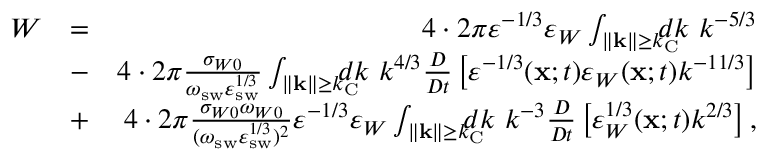<formula> <loc_0><loc_0><loc_500><loc_500>\begin{array} { r l r } { W } & { = } & { 4 \cdot 2 \pi \varepsilon ^ { - 1 / 3 } \varepsilon _ { W } \int _ { \| { k } \| \geq k _ { C } } \, d k \ k ^ { - 5 / 3 } } \\ & { - } & { 4 \cdot 2 \pi \frac { \sigma _ { W 0 } } { \omega _ { s w } \varepsilon _ { s w } ^ { 1 / 3 } } \int _ { \| { k } \| \geq k _ { C } } \, d k \ k ^ { 4 / 3 } \frac { D } { D t } \left [ { \varepsilon ^ { - 1 / 3 } ( { x } ; t ) \varepsilon _ { W } ( { x } ; t ) k ^ { - 1 1 / 3 } } \right ] } \\ & { + } & { 4 \cdot 2 \pi \frac { \sigma _ { W 0 } \omega _ { W 0 } } { ( \omega _ { s w } \varepsilon _ { s w } ^ { 1 / 3 } ) ^ { 2 } } \varepsilon ^ { - 1 / 3 } \varepsilon _ { W } \int _ { \| { k } \| \geq k _ { C } } \, d k \ k ^ { - 3 } \frac { D } { D t } \left [ { \varepsilon _ { W } ^ { 1 / 3 } ( { x } ; t ) k ^ { 2 / 3 } } \right ] , } \end{array}</formula> 